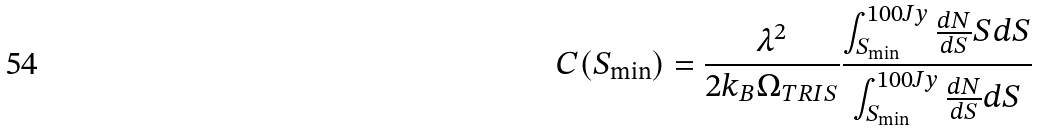Convert formula to latex. <formula><loc_0><loc_0><loc_500><loc_500>C ( S _ { \min } ) = \frac { \lambda ^ { 2 } } { 2 k _ { B } \Omega _ { T R I S } } \frac { \int _ { S _ { \min } } ^ { 1 0 0 J y } \frac { d N } { d S } S d S } { \int _ { S _ { \min } } ^ { 1 0 0 J y } \frac { d N } { d S } d S }</formula> 